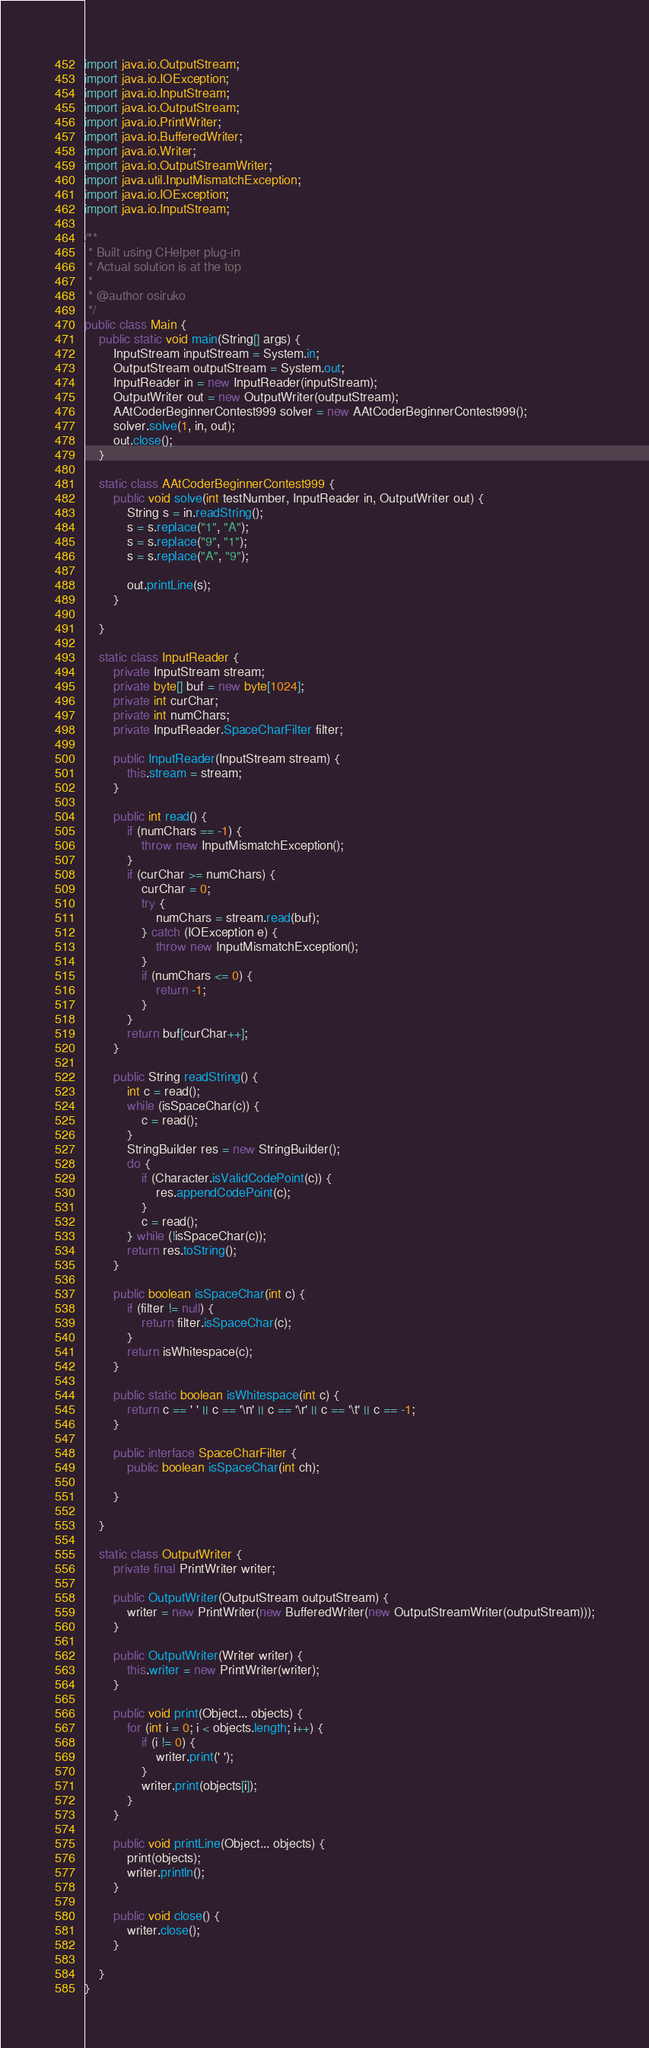Convert code to text. <code><loc_0><loc_0><loc_500><loc_500><_Java_>import java.io.OutputStream;
import java.io.IOException;
import java.io.InputStream;
import java.io.OutputStream;
import java.io.PrintWriter;
import java.io.BufferedWriter;
import java.io.Writer;
import java.io.OutputStreamWriter;
import java.util.InputMismatchException;
import java.io.IOException;
import java.io.InputStream;

/**
 * Built using CHelper plug-in
 * Actual solution is at the top
 *
 * @author osiruko
 */
public class Main {
    public static void main(String[] args) {
        InputStream inputStream = System.in;
        OutputStream outputStream = System.out;
        InputReader in = new InputReader(inputStream);
        OutputWriter out = new OutputWriter(outputStream);
        AAtCoderBeginnerContest999 solver = new AAtCoderBeginnerContest999();
        solver.solve(1, in, out);
        out.close();
    }

    static class AAtCoderBeginnerContest999 {
        public void solve(int testNumber, InputReader in, OutputWriter out) {
            String s = in.readString();
            s = s.replace("1", "A");
            s = s.replace("9", "1");
            s = s.replace("A", "9");

            out.printLine(s);
        }

    }

    static class InputReader {
        private InputStream stream;
        private byte[] buf = new byte[1024];
        private int curChar;
        private int numChars;
        private InputReader.SpaceCharFilter filter;

        public InputReader(InputStream stream) {
            this.stream = stream;
        }

        public int read() {
            if (numChars == -1) {
                throw new InputMismatchException();
            }
            if (curChar >= numChars) {
                curChar = 0;
                try {
                    numChars = stream.read(buf);
                } catch (IOException e) {
                    throw new InputMismatchException();
                }
                if (numChars <= 0) {
                    return -1;
                }
            }
            return buf[curChar++];
        }

        public String readString() {
            int c = read();
            while (isSpaceChar(c)) {
                c = read();
            }
            StringBuilder res = new StringBuilder();
            do {
                if (Character.isValidCodePoint(c)) {
                    res.appendCodePoint(c);
                }
                c = read();
            } while (!isSpaceChar(c));
            return res.toString();
        }

        public boolean isSpaceChar(int c) {
            if (filter != null) {
                return filter.isSpaceChar(c);
            }
            return isWhitespace(c);
        }

        public static boolean isWhitespace(int c) {
            return c == ' ' || c == '\n' || c == '\r' || c == '\t' || c == -1;
        }

        public interface SpaceCharFilter {
            public boolean isSpaceChar(int ch);

        }

    }

    static class OutputWriter {
        private final PrintWriter writer;

        public OutputWriter(OutputStream outputStream) {
            writer = new PrintWriter(new BufferedWriter(new OutputStreamWriter(outputStream)));
        }

        public OutputWriter(Writer writer) {
            this.writer = new PrintWriter(writer);
        }

        public void print(Object... objects) {
            for (int i = 0; i < objects.length; i++) {
                if (i != 0) {
                    writer.print(' ');
                }
                writer.print(objects[i]);
            }
        }

        public void printLine(Object... objects) {
            print(objects);
            writer.println();
        }

        public void close() {
            writer.close();
        }

    }
}

</code> 